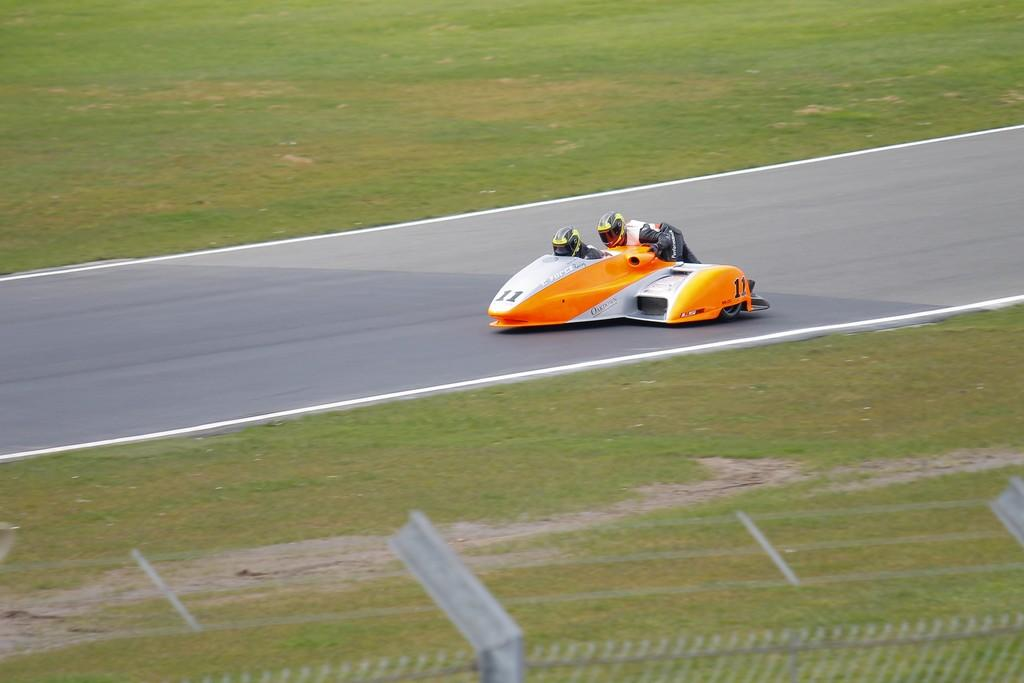What is the main subject of the image? The main subject of the image is a racing car. What is the racing car doing in the image? The racing car is moving on the road in the image. Are there any people inside the racing car? Yes, there are persons inside the racing car. What can be seen on both sides of the road in the image? There is grass on both sides of the road in the image. What is located in the front of the image? There is a fence in the front of the image. What fictional character is providing a caption for the image? There is no fictional character providing a caption for the image, as the image does not contain any text or captions. Can you tell me how many toes are visible in the image? There are no toes visible in the image, as the image does not contain any people or body parts. 